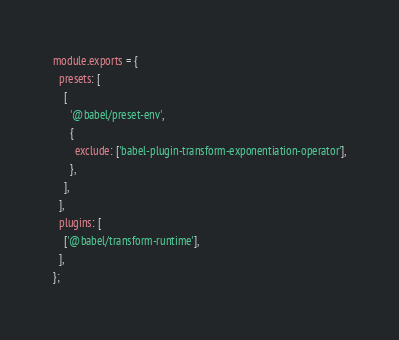<code> <loc_0><loc_0><loc_500><loc_500><_JavaScript_>module.exports = {
  presets: [
    [
      '@babel/preset-env',
      {
        exclude: ['babel-plugin-transform-exponentiation-operator'],
      },
    ],
  ],
  plugins: [
    ['@babel/transform-runtime'],
  ],
};
</code> 